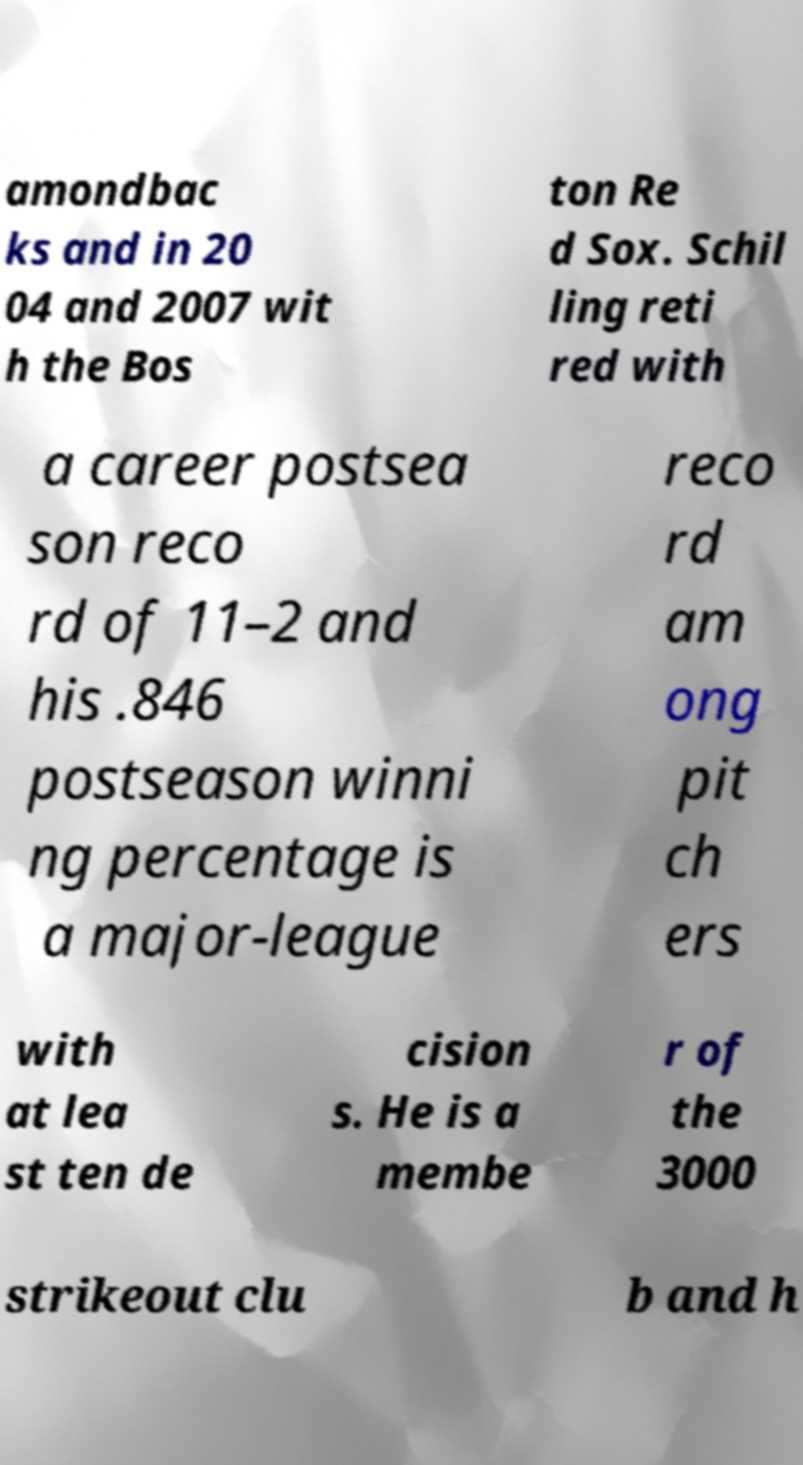What messages or text are displayed in this image? I need them in a readable, typed format. amondbac ks and in 20 04 and 2007 wit h the Bos ton Re d Sox. Schil ling reti red with a career postsea son reco rd of 11–2 and his .846 postseason winni ng percentage is a major-league reco rd am ong pit ch ers with at lea st ten de cision s. He is a membe r of the 3000 strikeout clu b and h 